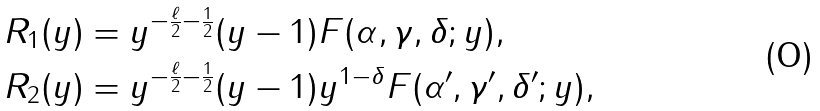<formula> <loc_0><loc_0><loc_500><loc_500>R _ { 1 } ( y ) & = y ^ { - \frac { \ell } { 2 } - \frac { 1 } { 2 } } ( y - 1 ) F ( \alpha , \gamma , \delta ; y ) , \\ R _ { 2 } ( y ) & = y ^ { - \frac { \ell } { 2 } - \frac { 1 } { 2 } } ( y - 1 ) y ^ { 1 - \delta } F ( \alpha ^ { \prime } , \gamma ^ { \prime } , \delta ^ { \prime } ; y ) ,</formula> 